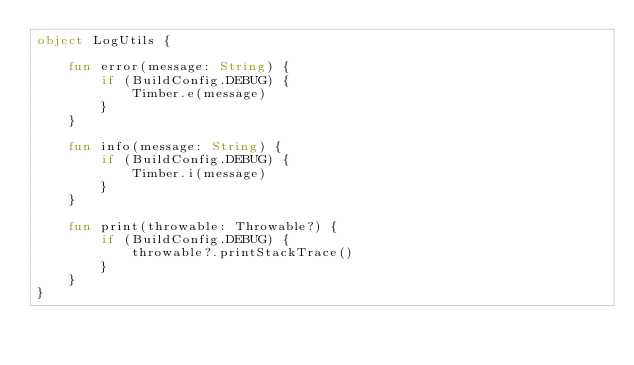<code> <loc_0><loc_0><loc_500><loc_500><_Kotlin_>object LogUtils {

    fun error(message: String) {
        if (BuildConfig.DEBUG) {
            Timber.e(message)
        }
    }

    fun info(message: String) {
        if (BuildConfig.DEBUG) {
            Timber.i(message)
        }
    }

    fun print(throwable: Throwable?) {
        if (BuildConfig.DEBUG) {
            throwable?.printStackTrace()
        }
    }
}</code> 